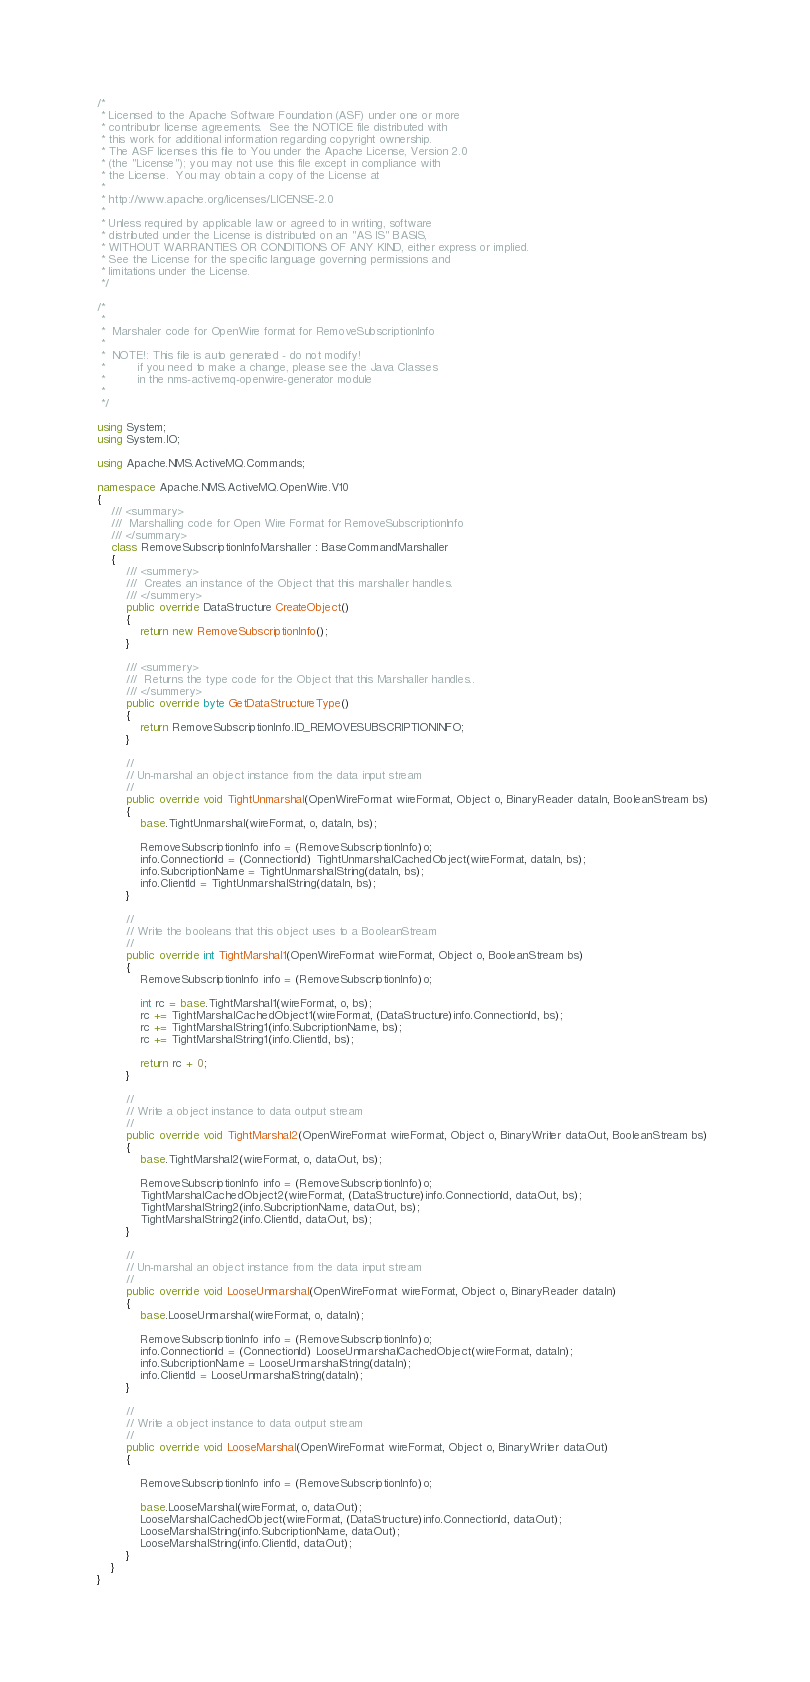<code> <loc_0><loc_0><loc_500><loc_500><_C#_>/*
 * Licensed to the Apache Software Foundation (ASF) under one or more
 * contributor license agreements.  See the NOTICE file distributed with
 * this work for additional information regarding copyright ownership.
 * The ASF licenses this file to You under the Apache License, Version 2.0
 * (the "License"); you may not use this file except in compliance with
 * the License.  You may obtain a copy of the License at
 *
 * http://www.apache.org/licenses/LICENSE-2.0
 *
 * Unless required by applicable law or agreed to in writing, software
 * distributed under the License is distributed on an "AS IS" BASIS,
 * WITHOUT WARRANTIES OR CONDITIONS OF ANY KIND, either express or implied.
 * See the License for the specific language governing permissions and
 * limitations under the License.
 */

/*
 *
 *  Marshaler code for OpenWire format for RemoveSubscriptionInfo
 *
 *  NOTE!: This file is auto generated - do not modify!
 *         if you need to make a change, please see the Java Classes
 *         in the nms-activemq-openwire-generator module
 *
 */

using System;
using System.IO;

using Apache.NMS.ActiveMQ.Commands;

namespace Apache.NMS.ActiveMQ.OpenWire.V10
{
    /// <summary>
    ///  Marshalling code for Open Wire Format for RemoveSubscriptionInfo
    /// </summary>
    class RemoveSubscriptionInfoMarshaller : BaseCommandMarshaller
    {
        /// <summery>
        ///  Creates an instance of the Object that this marshaller handles.
        /// </summery>
        public override DataStructure CreateObject() 
        {
            return new RemoveSubscriptionInfo();
        }

        /// <summery>
        ///  Returns the type code for the Object that this Marshaller handles..
        /// </summery>
        public override byte GetDataStructureType() 
        {
            return RemoveSubscriptionInfo.ID_REMOVESUBSCRIPTIONINFO;
        }

        // 
        // Un-marshal an object instance from the data input stream
        // 
        public override void TightUnmarshal(OpenWireFormat wireFormat, Object o, BinaryReader dataIn, BooleanStream bs) 
        {
            base.TightUnmarshal(wireFormat, o, dataIn, bs);

            RemoveSubscriptionInfo info = (RemoveSubscriptionInfo)o;
            info.ConnectionId = (ConnectionId) TightUnmarshalCachedObject(wireFormat, dataIn, bs);
            info.SubcriptionName = TightUnmarshalString(dataIn, bs);
            info.ClientId = TightUnmarshalString(dataIn, bs);
        }

        //
        // Write the booleans that this object uses to a BooleanStream
        //
        public override int TightMarshal1(OpenWireFormat wireFormat, Object o, BooleanStream bs)
        {
            RemoveSubscriptionInfo info = (RemoveSubscriptionInfo)o;

            int rc = base.TightMarshal1(wireFormat, o, bs);
            rc += TightMarshalCachedObject1(wireFormat, (DataStructure)info.ConnectionId, bs);
            rc += TightMarshalString1(info.SubcriptionName, bs);
            rc += TightMarshalString1(info.ClientId, bs);

            return rc + 0;
        }

        // 
        // Write a object instance to data output stream
        //
        public override void TightMarshal2(OpenWireFormat wireFormat, Object o, BinaryWriter dataOut, BooleanStream bs)
        {
            base.TightMarshal2(wireFormat, o, dataOut, bs);

            RemoveSubscriptionInfo info = (RemoveSubscriptionInfo)o;
            TightMarshalCachedObject2(wireFormat, (DataStructure)info.ConnectionId, dataOut, bs);
            TightMarshalString2(info.SubcriptionName, dataOut, bs);
            TightMarshalString2(info.ClientId, dataOut, bs);
        }

        // 
        // Un-marshal an object instance from the data input stream
        // 
        public override void LooseUnmarshal(OpenWireFormat wireFormat, Object o, BinaryReader dataIn) 
        {
            base.LooseUnmarshal(wireFormat, o, dataIn);

            RemoveSubscriptionInfo info = (RemoveSubscriptionInfo)o;
            info.ConnectionId = (ConnectionId) LooseUnmarshalCachedObject(wireFormat, dataIn);
            info.SubcriptionName = LooseUnmarshalString(dataIn);
            info.ClientId = LooseUnmarshalString(dataIn);
        }

        // 
        // Write a object instance to data output stream
        //
        public override void LooseMarshal(OpenWireFormat wireFormat, Object o, BinaryWriter dataOut)
        {

            RemoveSubscriptionInfo info = (RemoveSubscriptionInfo)o;

            base.LooseMarshal(wireFormat, o, dataOut);
            LooseMarshalCachedObject(wireFormat, (DataStructure)info.ConnectionId, dataOut);
            LooseMarshalString(info.SubcriptionName, dataOut);
            LooseMarshalString(info.ClientId, dataOut);
        }
    }
}
</code> 